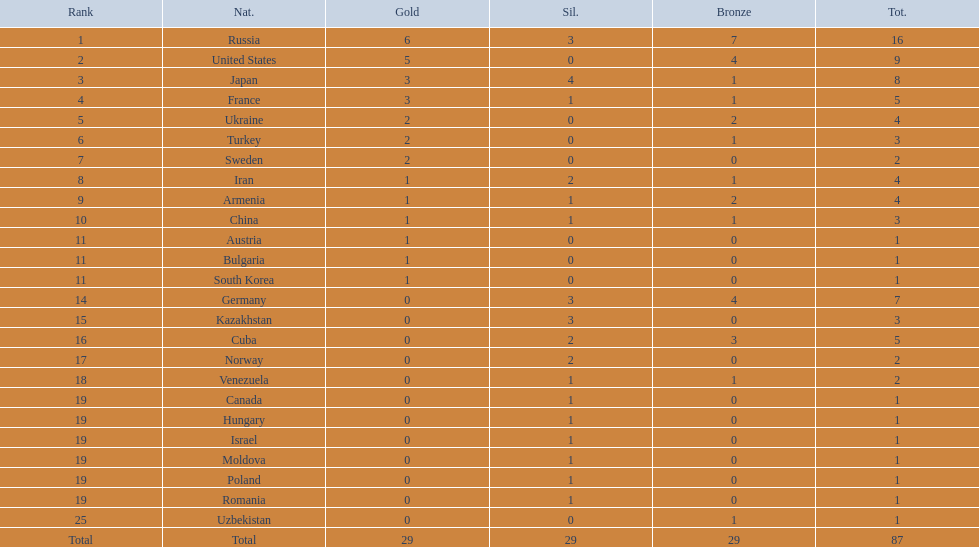How many countries competed? Israel. How many total medals did russia win? 16. What country won only 1 medal? Uzbekistan. 